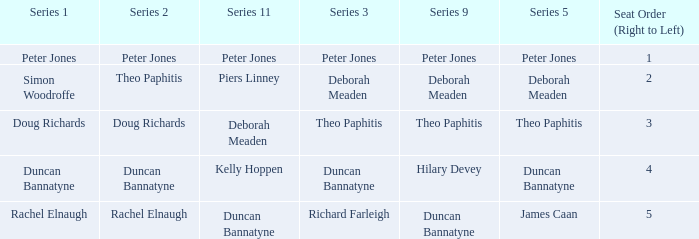Which Series 1 has a Series 11 of peter jones? Peter Jones. 